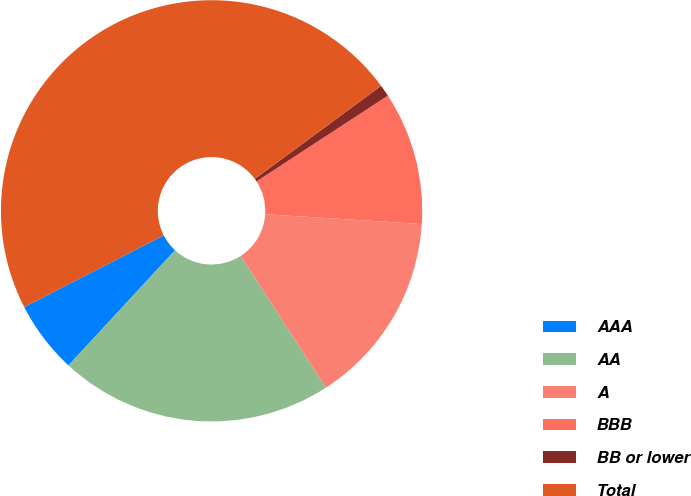Convert chart to OTSL. <chart><loc_0><loc_0><loc_500><loc_500><pie_chart><fcel>AAA<fcel>AA<fcel>A<fcel>BBB<fcel>BB or lower<fcel>Total<nl><fcel>5.56%<fcel>21.02%<fcel>14.87%<fcel>10.21%<fcel>0.9%<fcel>47.45%<nl></chart> 